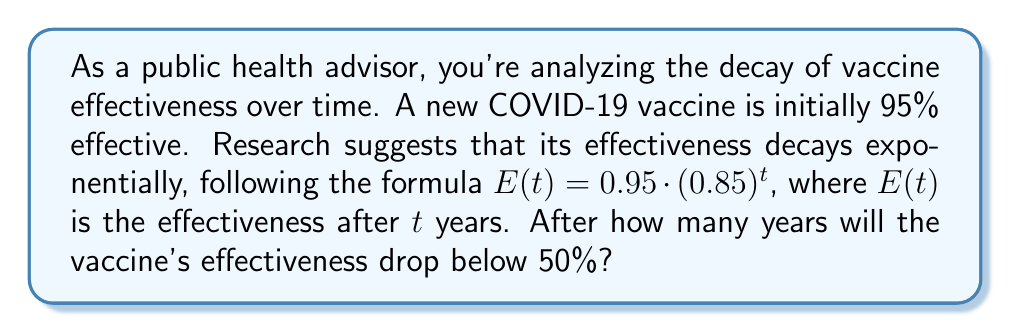Provide a solution to this math problem. To solve this problem, we need to determine when $E(t)$ becomes less than 0.50 (50%).

1) We start with the given formula: $E(t) = 0.95 \cdot (0.85)^t$

2) We want to find $t$ when $E(t) < 0.50$:

   $0.95 \cdot (0.85)^t < 0.50$

3) Divide both sides by 0.95:

   $(0.85)^t < \frac{0.50}{0.95} \approx 0.5263$

4) Take the natural logarithm of both sides:

   $t \cdot \ln(0.85) < \ln(0.5263)$

5) Divide both sides by $\ln(0.85)$ (note that $\ln(0.85)$ is negative):

   $t > \frac{\ln(0.5263)}{\ln(0.85)} \approx 4.2986$

6) Since we're looking for the number of years, we need to round up to the next whole number.

Therefore, the vaccine's effectiveness will drop below 50% after 5 years.
Answer: 5 years 